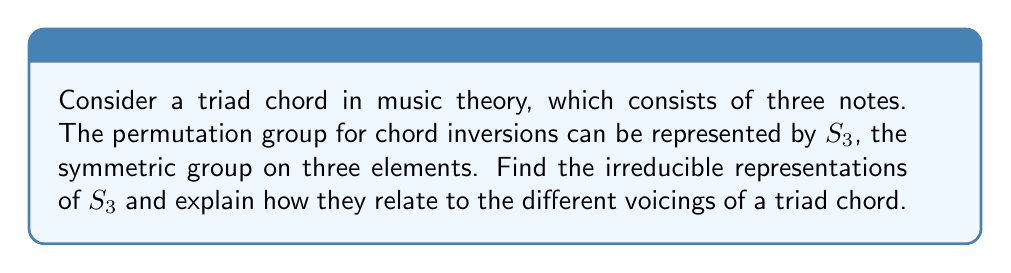Solve this math problem. To find the irreducible representations of $S_3$, we'll follow these steps:

1) First, recall that the number of irreducible representations is equal to the number of conjugacy classes. $S_3$ has 3 conjugacy classes:
   - Identity: $\{e\}$
   - Transpositions: $\{(12), (23), (13)\}$
   - 3-cycles: $\{(123), (132)\}$

2) The dimensions of these irreducible representations must satisfy:
   $1^2 + 1^2 + 2^2 = 6$ (order of $S_3$)

3) Therefore, we expect two 1-dimensional representations and one 2-dimensional representation.

4) The 1-dimensional representations are:
   - Trivial representation: $\rho_1(g) = 1$ for all $g \in S_3$
   - Sign representation: $\rho_2(g) = \text{sgn}(g)$ (1 for even permutations, -1 for odd)

5) For the 2-dimensional representation $\rho_3$, we can use the following matrices:
   $$\rho_3((12)) = \begin{pmatrix} -1/2 & \sqrt{3}/2 \\ \sqrt{3}/2 & 1/2 \end{pmatrix}$$
   $$\rho_3((123)) = \begin{pmatrix} -1/2 & -\sqrt{3}/2 \\ \sqrt{3}/2 & -1/2 \end{pmatrix}$$

6) Relating to triad chords:
   - $\rho_1$ corresponds to the root position of the chord (unchanged under inversion)
   - $\rho_2$ distinguishes between root position/second inversion and first inversion
   - $\rho_3$ fully describes all possible inversions and their relationships

For a vocalist, understanding these representations can help in recognizing and performing different chord voicings, enhancing their ability to harmonize and improvise within a musical piece.
Answer: The irreducible representations of $S_3$ are: one trivial 1D, one sign 1D, and one 2D representation. 